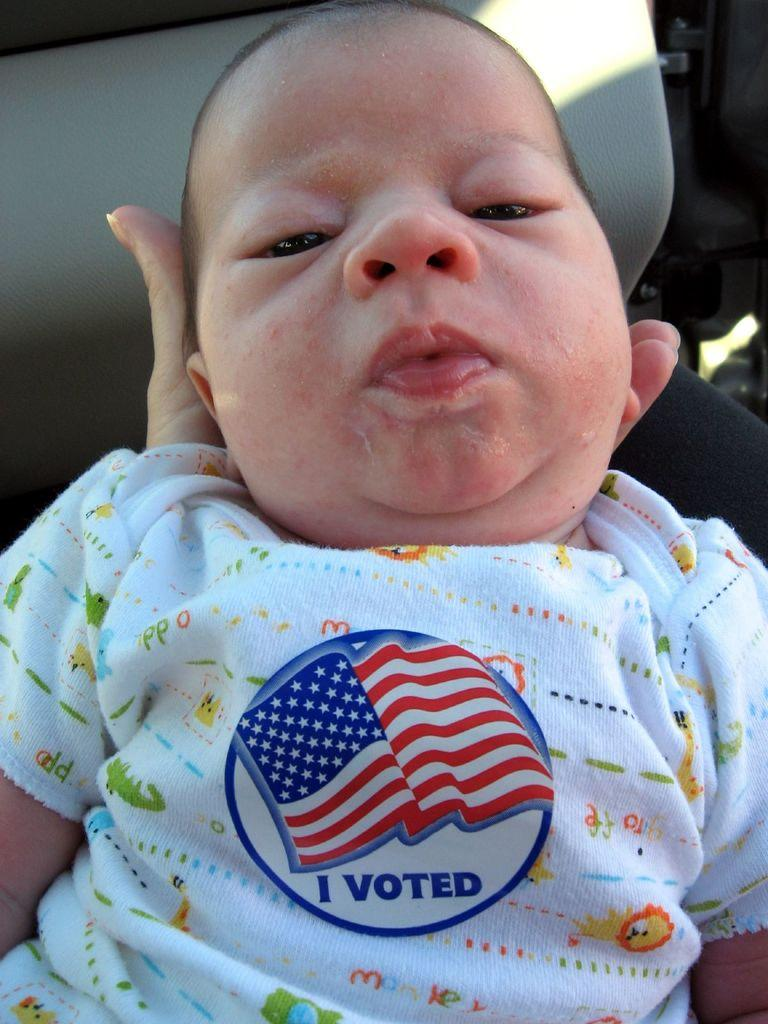Who is present in the image? There is a person in the image. What is the person holding? The person is holding an infant. What is the infant wearing? The infant is wearing a t-shirt. What is written on the t-shirt? The t-shirt has the text "I Voted" written on it. What type of beam is supporting the roof in the image? There is no mention of a roof or any beams in the image; it features a person holding an infant with a t-shirt that says "I Voted." 